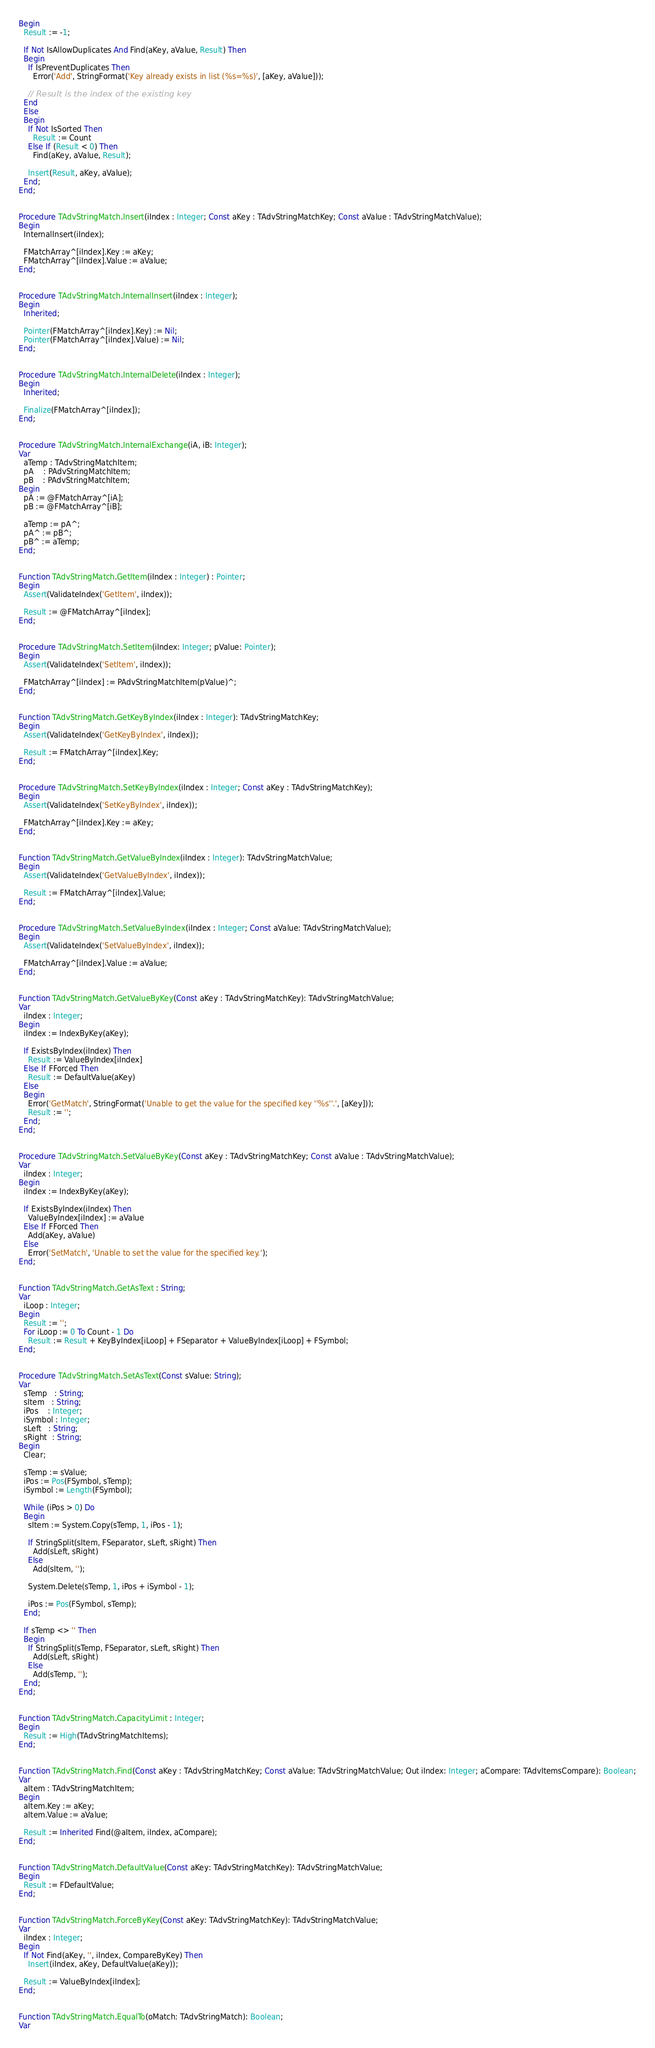<code> <loc_0><loc_0><loc_500><loc_500><_Pascal_>Begin
  Result := -1;

  If Not IsAllowDuplicates And Find(aKey, aValue, Result) Then
  Begin
    If IsPreventDuplicates Then
      Error('Add', StringFormat('Key already exists in list (%s=%s)', [aKey, aValue]));

    // Result is the index of the existing key
  End   
  Else
  Begin 
    If Not IsSorted Then
      Result := Count
    Else If (Result < 0) Then
      Find(aKey, aValue, Result);

    Insert(Result, aKey, aValue);
  End;  
End;  


Procedure TAdvStringMatch.Insert(iIndex : Integer; Const aKey : TAdvStringMatchKey; Const aValue : TAdvStringMatchValue);
Begin 
  InternalInsert(iIndex);

  FMatchArray^[iIndex].Key := aKey;
  FMatchArray^[iIndex].Value := aValue;
End;  


Procedure TAdvStringMatch.InternalInsert(iIndex : Integer);
Begin 
  Inherited;

  Pointer(FMatchArray^[iIndex].Key) := Nil;
  Pointer(FMatchArray^[iIndex].Value) := Nil;
End;  


Procedure TAdvStringMatch.InternalDelete(iIndex : Integer);
Begin 
  Inherited;

  Finalize(FMatchArray^[iIndex]);  
End;  


Procedure TAdvStringMatch.InternalExchange(iA, iB: Integer);
Var
  aTemp : TAdvStringMatchItem;
  pA    : PAdvStringMatchItem;
  pB    : PAdvStringMatchItem;
Begin 
  pA := @FMatchArray^[iA];
  pB := @FMatchArray^[iB];

  aTemp := pA^;
  pA^ := pB^;
  pB^ := aTemp;
End;  


Function TAdvStringMatch.GetItem(iIndex : Integer) : Pointer;
Begin 
  Assert(ValidateIndex('GetItem', iIndex));

  Result := @FMatchArray^[iIndex];
End;  


Procedure TAdvStringMatch.SetItem(iIndex: Integer; pValue: Pointer);
Begin 
  Assert(ValidateIndex('SetItem', iIndex));

  FMatchArray^[iIndex] := PAdvStringMatchItem(pValue)^;
End;  


Function TAdvStringMatch.GetKeyByIndex(iIndex : Integer): TAdvStringMatchKey;
Begin 
  Assert(ValidateIndex('GetKeyByIndex', iIndex));

  Result := FMatchArray^[iIndex].Key;
End;  


Procedure TAdvStringMatch.SetKeyByIndex(iIndex : Integer; Const aKey : TAdvStringMatchKey);
Begin 
  Assert(ValidateIndex('SetKeyByIndex', iIndex));

  FMatchArray^[iIndex].Key := aKey;
End;  


Function TAdvStringMatch.GetValueByIndex(iIndex : Integer): TAdvStringMatchValue;
Begin 
  Assert(ValidateIndex('GetValueByIndex', iIndex));

  Result := FMatchArray^[iIndex].Value;
End;  


Procedure TAdvStringMatch.SetValueByIndex(iIndex : Integer; Const aValue: TAdvStringMatchValue);
Begin 
  Assert(ValidateIndex('SetValueByIndex', iIndex));

  FMatchArray^[iIndex].Value := aValue;
End;  


Function TAdvStringMatch.GetValueByKey(Const aKey : TAdvStringMatchKey): TAdvStringMatchValue;
Var
  iIndex : Integer;
Begin 
  iIndex := IndexByKey(aKey);

  If ExistsByIndex(iIndex) Then
    Result := ValueByIndex[iIndex]
  Else If FForced Then
    Result := DefaultValue(aKey)
  Else
  Begin
    Error('GetMatch', StringFormat('Unable to get the value for the specified key ''%s''.', [aKey]));
    Result := '';
  End;
End;  


Procedure TAdvStringMatch.SetValueByKey(Const aKey : TAdvStringMatchKey; Const aValue : TAdvStringMatchValue);
Var
  iIndex : Integer;
Begin 
  iIndex := IndexByKey(aKey);

  If ExistsByIndex(iIndex) Then
    ValueByIndex[iIndex] := aValue
  Else If FForced Then
    Add(aKey, aValue)
  Else
    Error('SetMatch', 'Unable to set the value for the specified key.');
End;  


Function TAdvStringMatch.GetAsText : String;
Var
  iLoop : Integer;
Begin 
  Result := '';
  For iLoop := 0 To Count - 1 Do
    Result := Result + KeyByIndex[iLoop] + FSeparator + ValueByIndex[iLoop] + FSymbol;
End;  


Procedure TAdvStringMatch.SetAsText(Const sValue: String);
Var
  sTemp   : String;
  sItem   : String;
  iPos    : Integer;
  iSymbol : Integer;
  sLeft   : String;
  sRight  : String;
Begin 
  Clear;

  sTemp := sValue;
  iPos := Pos(FSymbol, sTemp);
  iSymbol := Length(FSymbol);

  While (iPos > 0) Do
  Begin 
    sItem := System.Copy(sTemp, 1, iPos - 1);

    If StringSplit(sItem, FSeparator, sLeft, sRight) Then
      Add(sLeft, sRight)
    Else
      Add(sItem, '');

    System.Delete(sTemp, 1, iPos + iSymbol - 1);

    iPos := Pos(FSymbol, sTemp);
  End;

  If sTemp <> '' Then
  Begin
    If StringSplit(sTemp, FSeparator, sLeft, sRight) Then
      Add(sLeft, sRight)
    Else
      Add(sTemp, '');
  End;  
End;  


Function TAdvStringMatch.CapacityLimit : Integer;
Begin 
  Result := High(TAdvStringMatchItems);
End;  


Function TAdvStringMatch.Find(Const aKey : TAdvStringMatchKey; Const aValue: TAdvStringMatchValue; Out iIndex: Integer; aCompare: TAdvItemsCompare): Boolean;
Var
  aItem : TAdvStringMatchItem;
Begin 
  aItem.Key := aKey;
  aItem.Value := aValue;

  Result := Inherited Find(@aItem, iIndex, aCompare);
End;  


Function TAdvStringMatch.DefaultValue(Const aKey: TAdvStringMatchKey): TAdvStringMatchValue;
Begin 
  Result := FDefaultValue;
End;  


Function TAdvStringMatch.ForceByKey(Const aKey: TAdvStringMatchKey): TAdvStringMatchValue;
Var
  iIndex : Integer;
Begin 
  If Not Find(aKey, '', iIndex, CompareByKey) Then
    Insert(iIndex, aKey, DefaultValue(aKey));

  Result := ValueByIndex[iIndex];
End;  


Function TAdvStringMatch.EqualTo(oMatch: TAdvStringMatch): Boolean;
Var</code> 